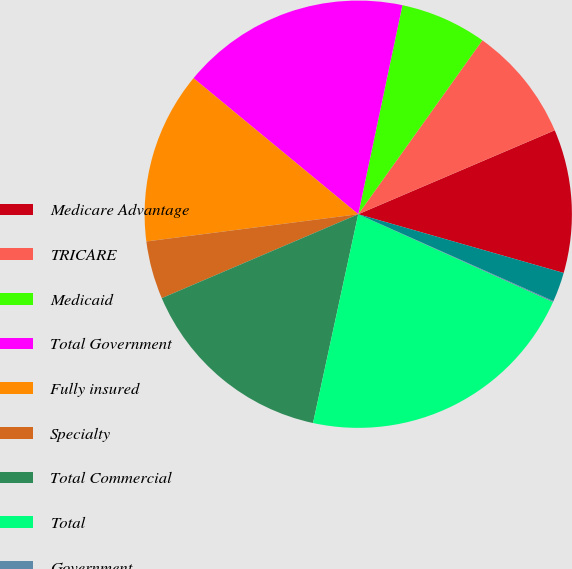Convert chart. <chart><loc_0><loc_0><loc_500><loc_500><pie_chart><fcel>Medicare Advantage<fcel>TRICARE<fcel>Medicaid<fcel>Total Government<fcel>Fully insured<fcel>Specialty<fcel>Total Commercial<fcel>Total<fcel>Government<fcel>Commercial<nl><fcel>10.86%<fcel>8.71%<fcel>6.55%<fcel>17.33%<fcel>13.02%<fcel>4.39%<fcel>15.18%<fcel>21.65%<fcel>0.08%<fcel>2.23%<nl></chart> 